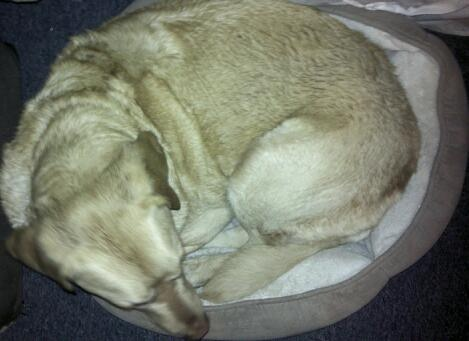Describe the objects in this image and their specific colors. I can see a dog in black, darkgray, gray, and beige tones in this image. 